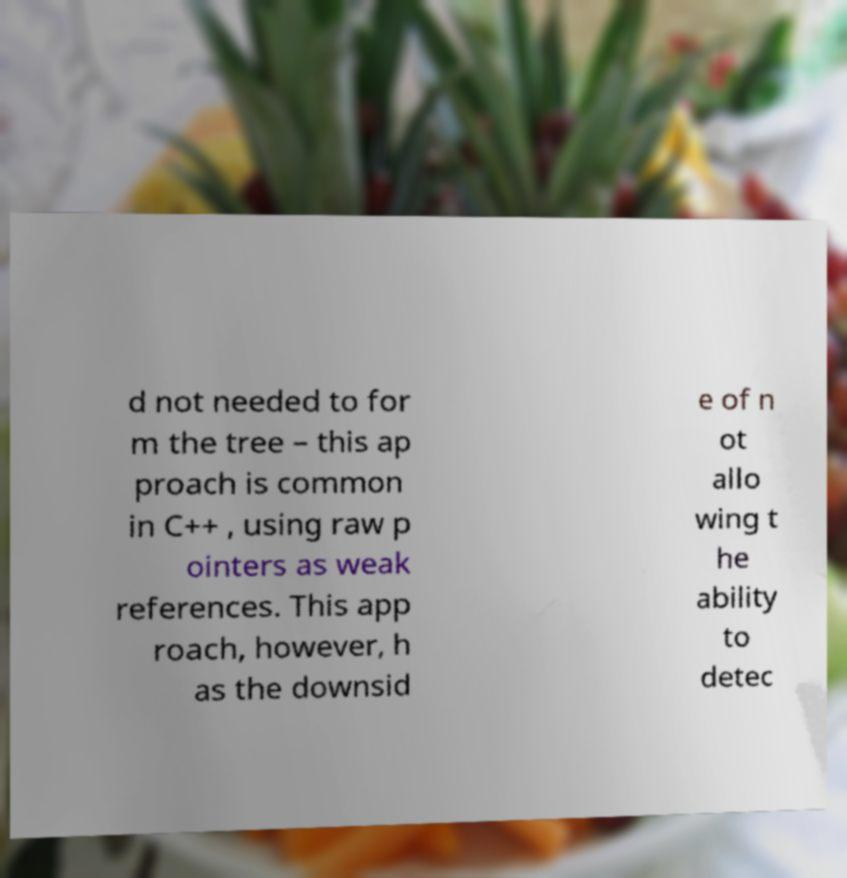What messages or text are displayed in this image? I need them in a readable, typed format. d not needed to for m the tree – this ap proach is common in C++ , using raw p ointers as weak references. This app roach, however, h as the downsid e of n ot allo wing t he ability to detec 